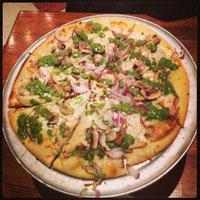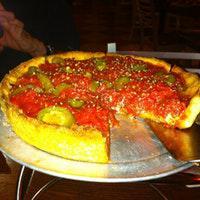The first image is the image on the left, the second image is the image on the right. Assess this claim about the two images: "Neither pizza is in a pan with sides, one is a New York style thin pizza, the other is a Chicago style deep dish.". Correct or not? Answer yes or no. Yes. The first image is the image on the left, the second image is the image on the right. Given the left and right images, does the statement "Both pizzas are cut into slices." hold true? Answer yes or no. Yes. 